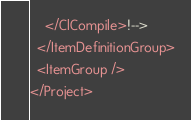Convert code to text. <code><loc_0><loc_0><loc_500><loc_500><_XML_>    </ClCompile>!-->
  </ItemDefinitionGroup>
  <ItemGroup />
</Project></code> 